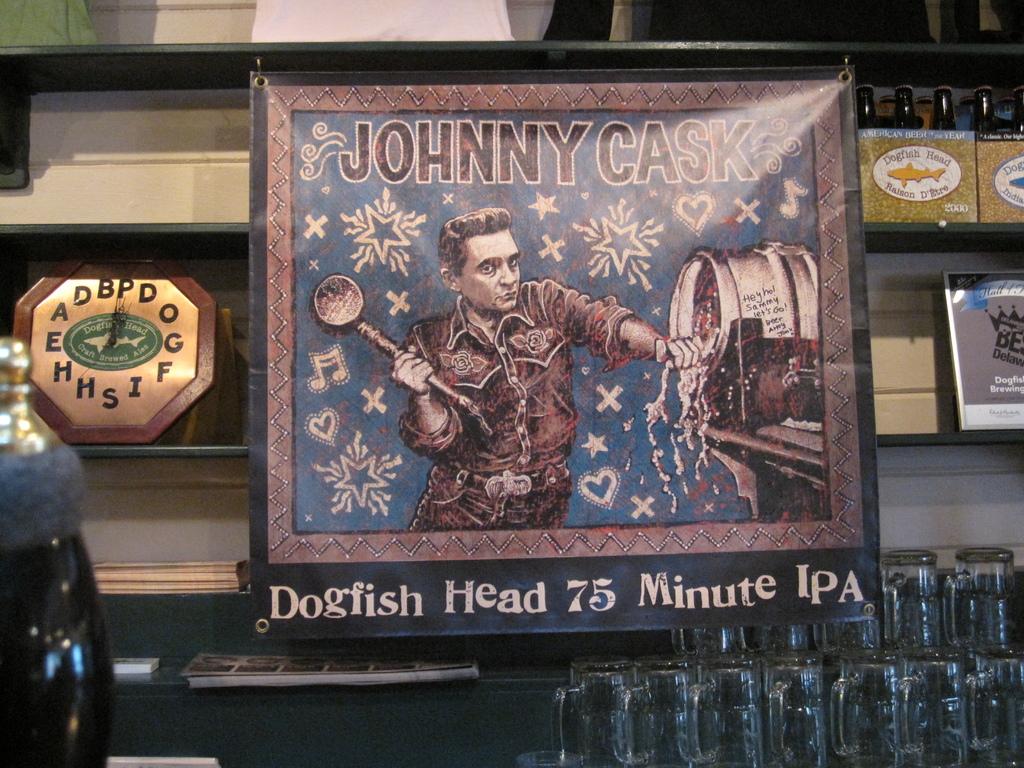What name is on the poster?
Your answer should be compact. Johnny cask. How many minutes is it?
Provide a succinct answer. 75. 